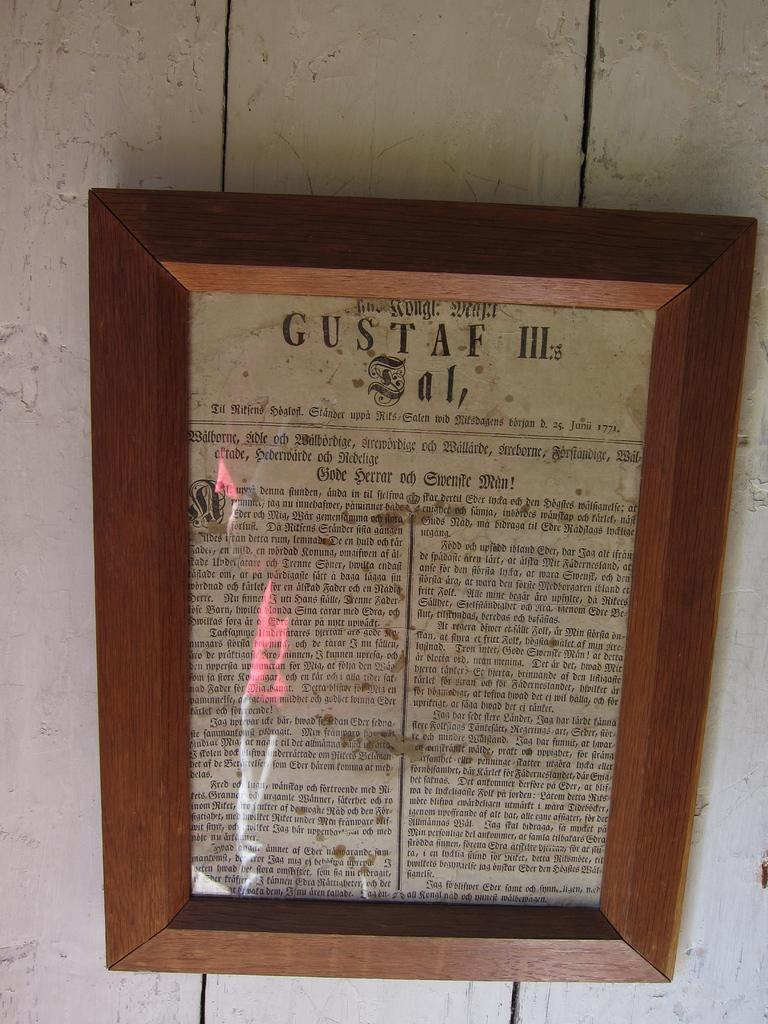<image>
Offer a succinct explanation of the picture presented. A very old newspaper called Gustaf III in a wooden frame. 